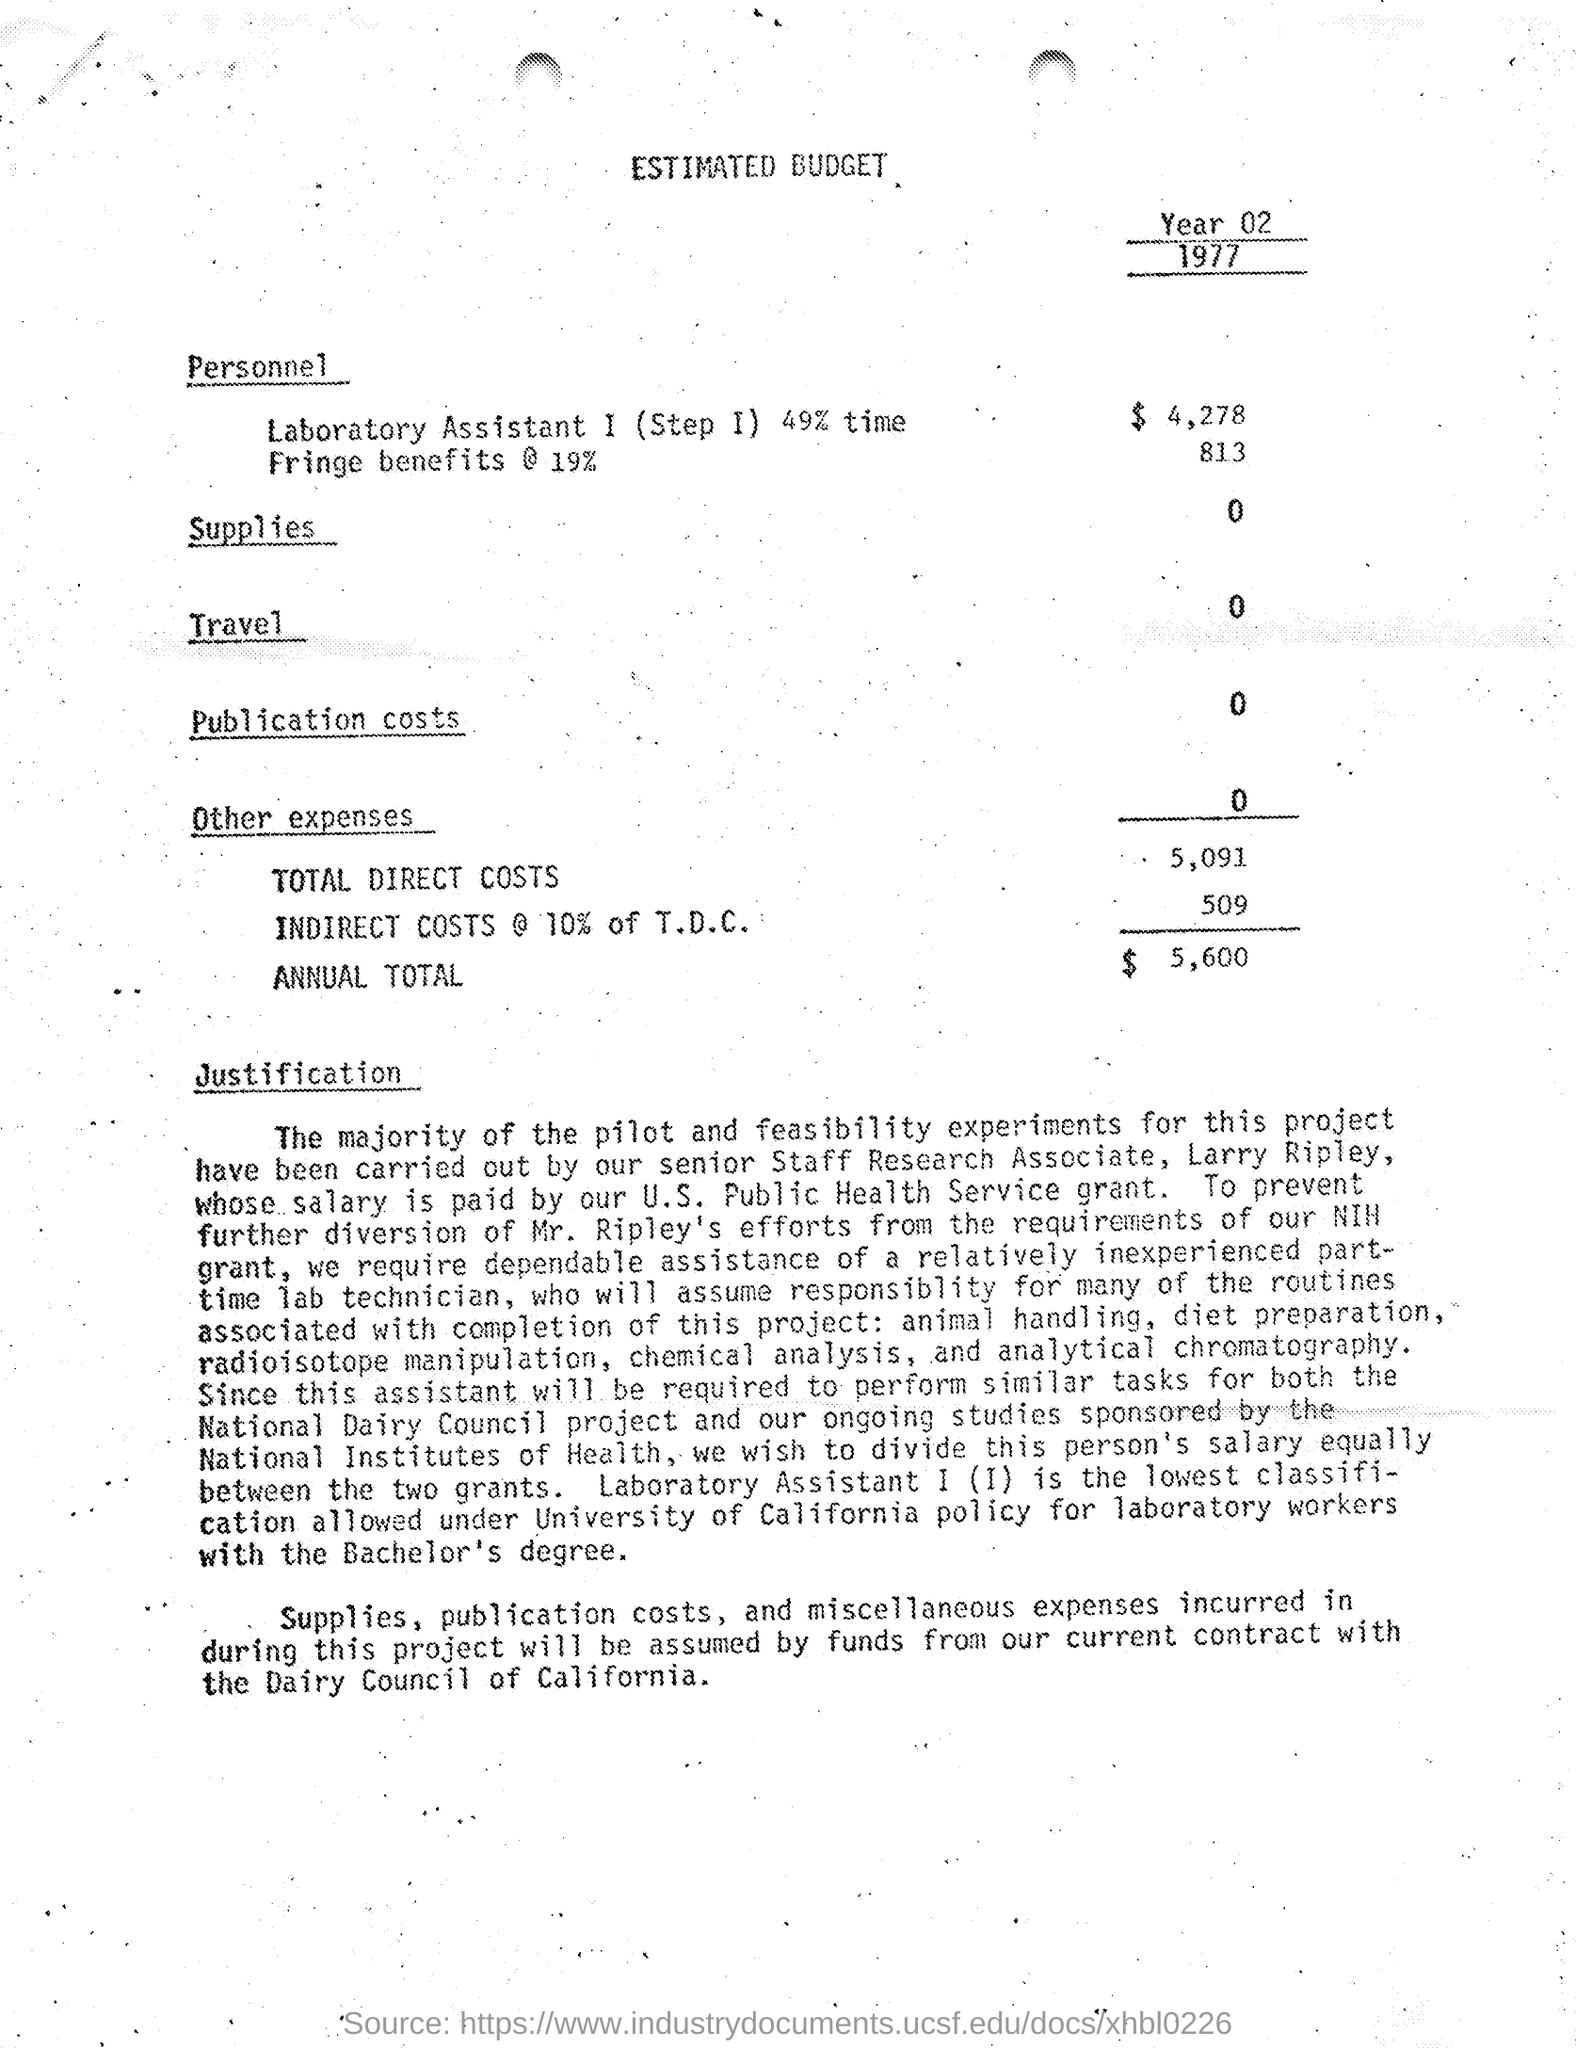what is the amount of other expenses mentioned in the estimated budget ? The amount of 'Other expenses' mentioned in the estimated budget is listed as $0. It is specified in the section just above the 'TOTAL DIRECT COSTS' line. 